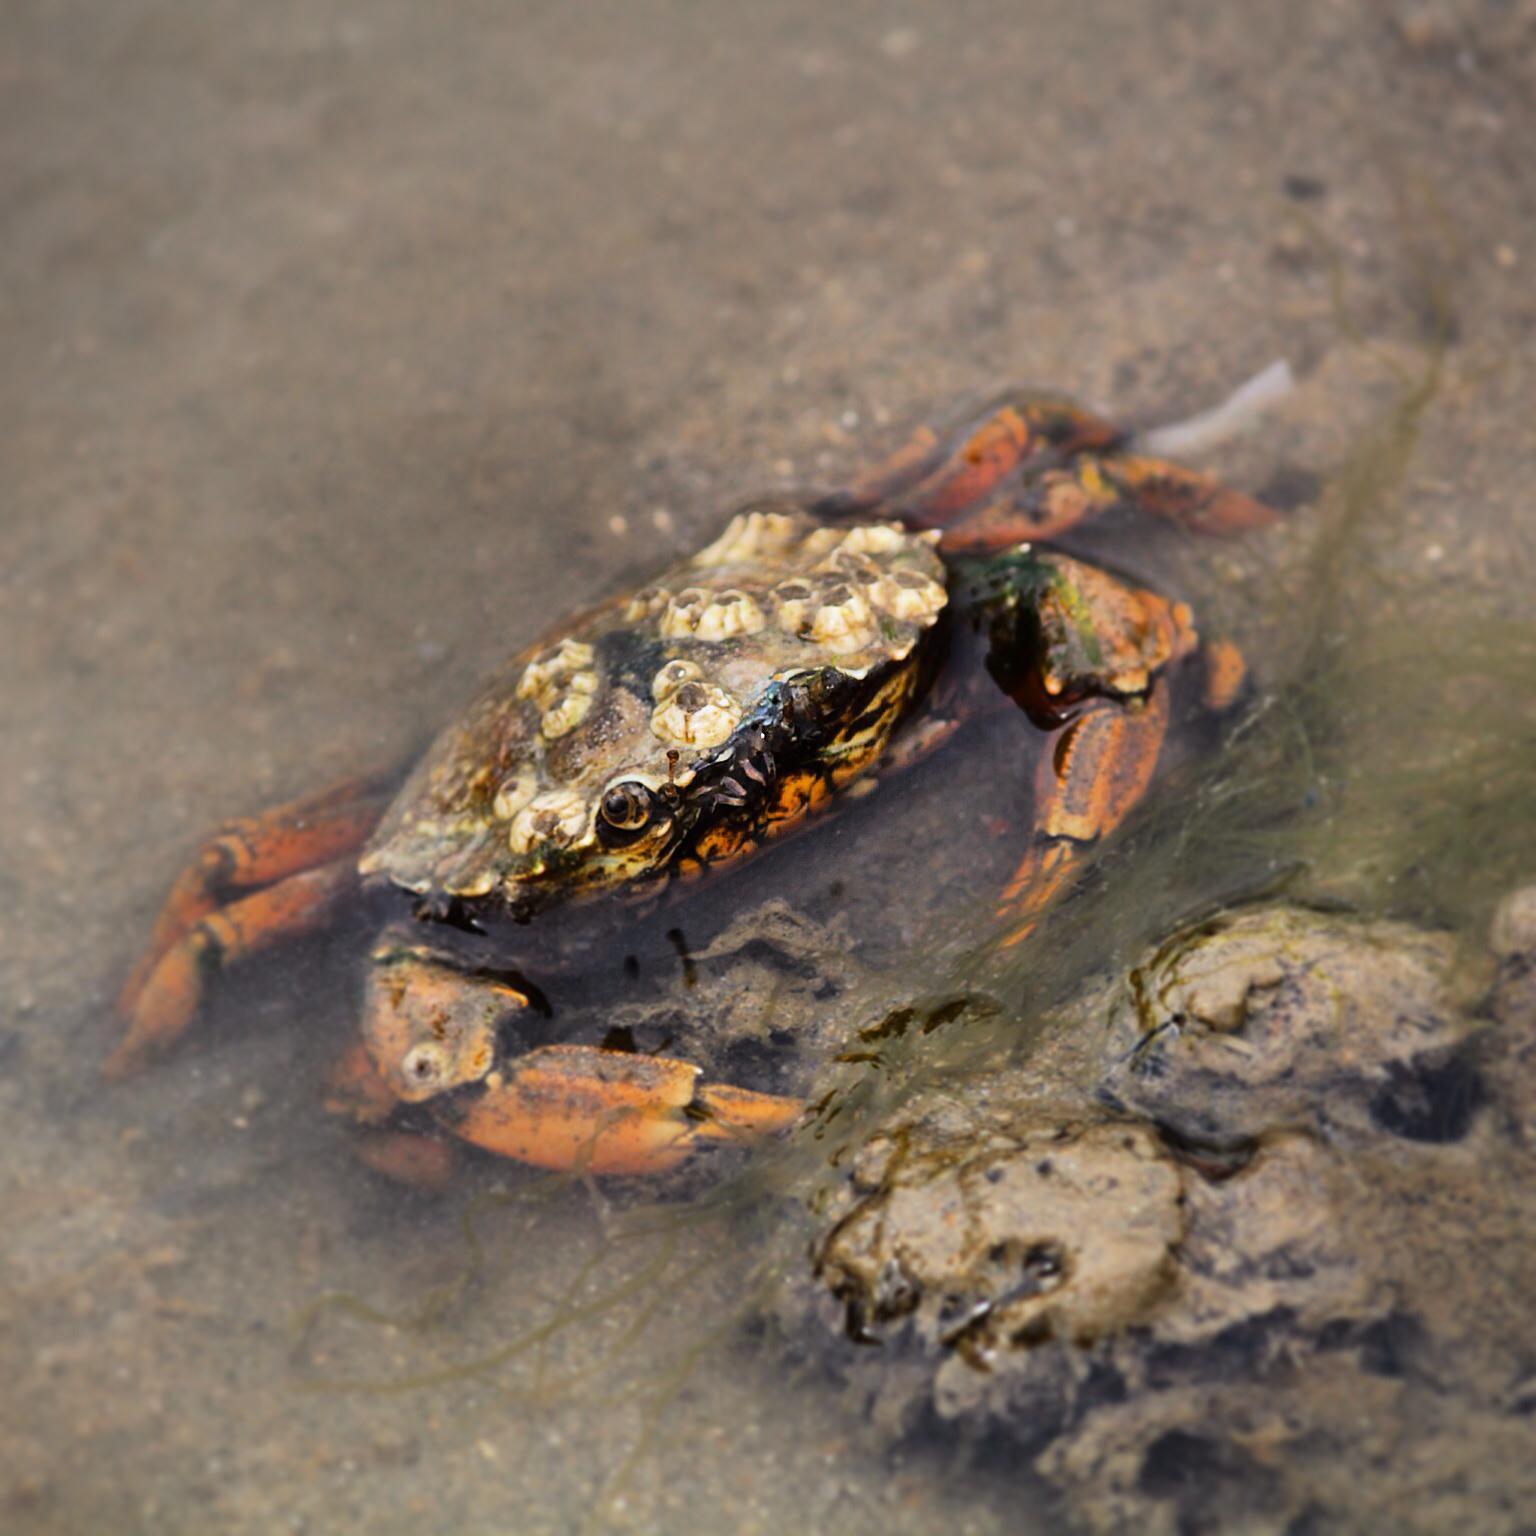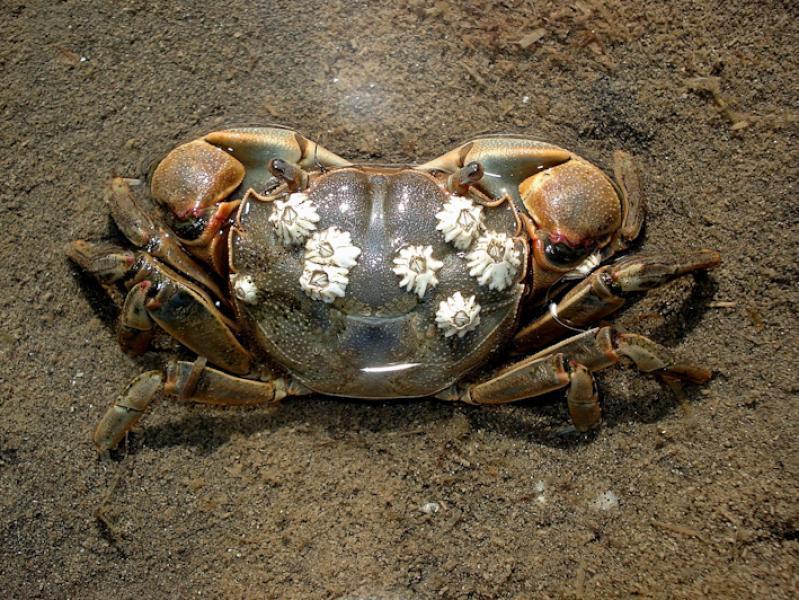The first image is the image on the left, the second image is the image on the right. Examine the images to the left and right. Is the description "The right image is a top-view of a crab on dry sand, with its shell face-up and dotted with barnacles." accurate? Answer yes or no. Yes. 